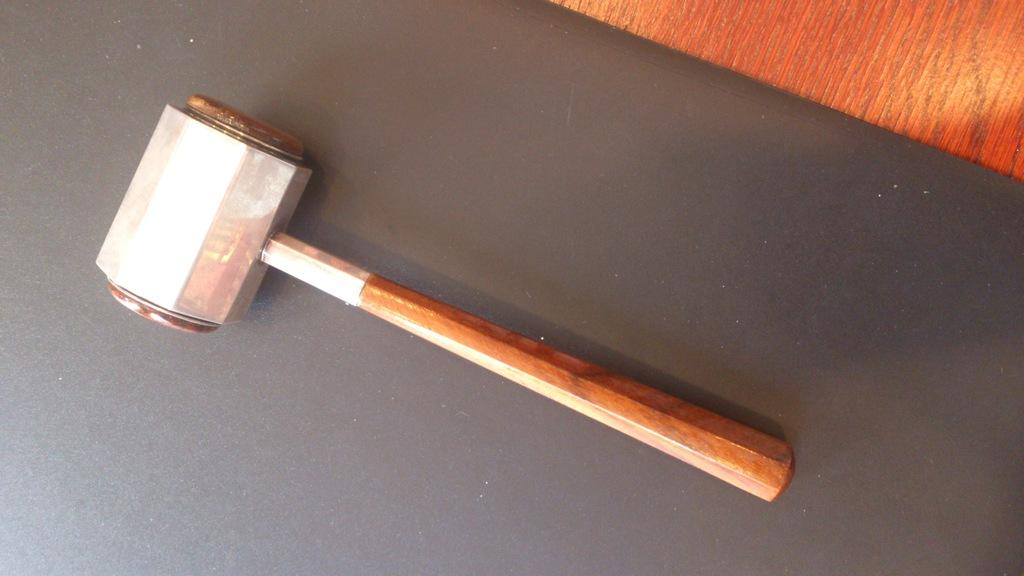What tool is visible in the image? There is a hammer in the image. What is the color of the surface the hammer is on? The hammer is on a black surface. What can be seen in the top right of the image? There is an object in the top right of the image. What is the color of the object in the top right of the image? The object is brown in color. How many letters are visible in the image? There are no letters present in the image. What type of animal can be seen in the image? There is no animal present in the image. 